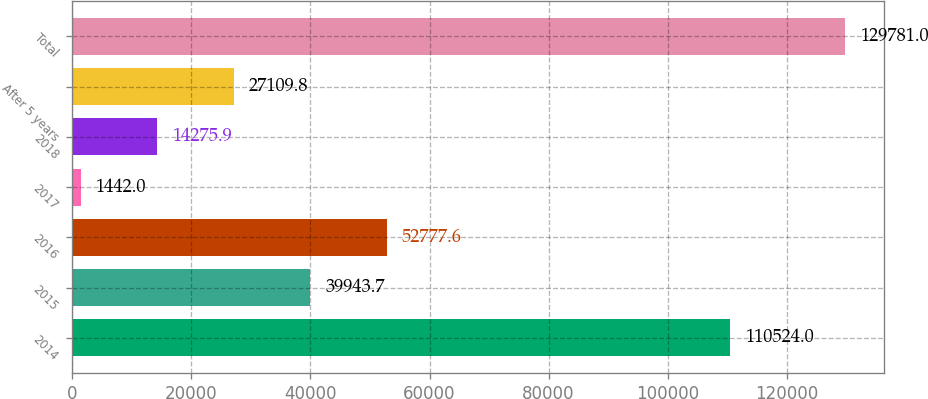Convert chart. <chart><loc_0><loc_0><loc_500><loc_500><bar_chart><fcel>2014<fcel>2015<fcel>2016<fcel>2017<fcel>2018<fcel>After 5 years<fcel>Total<nl><fcel>110524<fcel>39943.7<fcel>52777.6<fcel>1442<fcel>14275.9<fcel>27109.8<fcel>129781<nl></chart> 